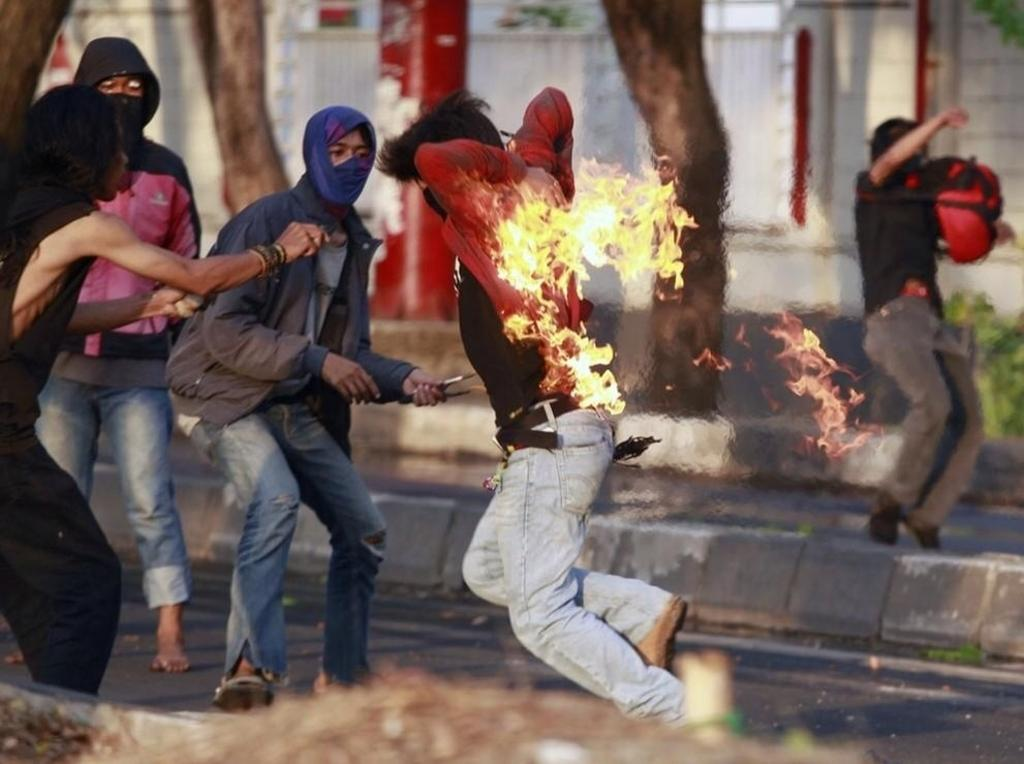Who is the main subject in the image? There is a man in the center of the image. What is happening to the man's shirt? The man has a fire on his shirt. What can be seen in the background of the image? There are people and trees in the background of the image. What is at the bottom of the image? There is a road at the bottom of the image. How does the hen distribute the fire on the man's shirt in the image? There is no hen present in the image, and therefore no such distribution can be observed. 